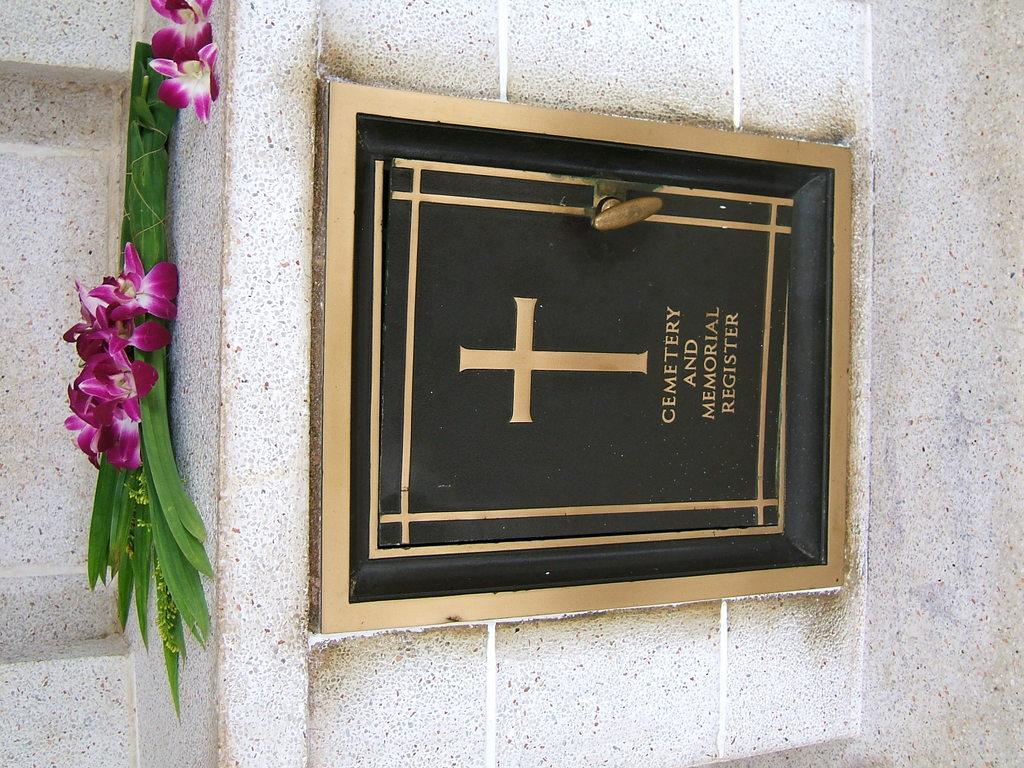<image>
Describe the image concisely. Sign that says "Cemetary and Memorial Register' under a flowe.r 